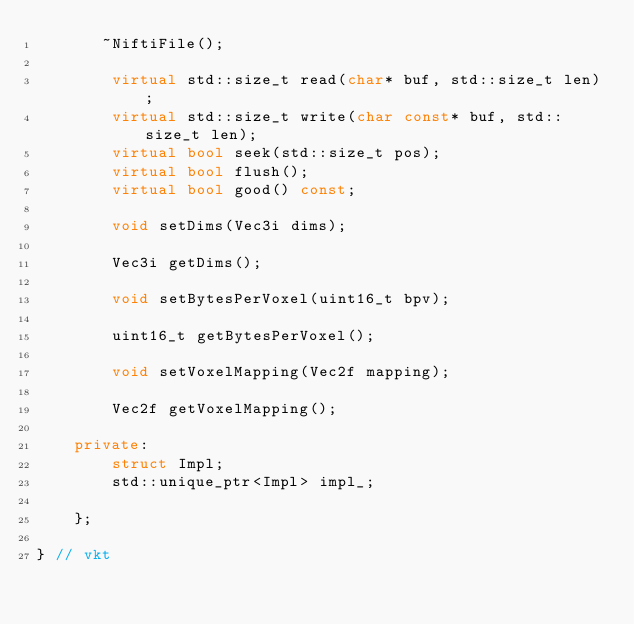Convert code to text. <code><loc_0><loc_0><loc_500><loc_500><_C++_>       ~NiftiFile();

        virtual std::size_t read(char* buf, std::size_t len);
        virtual std::size_t write(char const* buf, std::size_t len);
        virtual bool seek(std::size_t pos);
        virtual bool flush();
        virtual bool good() const;

        void setDims(Vec3i dims);

        Vec3i getDims();

        void setBytesPerVoxel(uint16_t bpv);

        uint16_t getBytesPerVoxel();

        void setVoxelMapping(Vec2f mapping);

        Vec2f getVoxelMapping();

    private:
        struct Impl;
        std::unique_ptr<Impl> impl_;

    };

} // vkt
</code> 